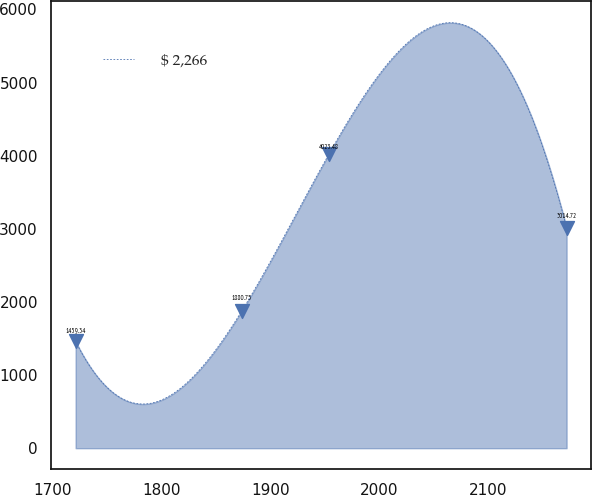Convert chart to OTSL. <chart><loc_0><loc_0><loc_500><loc_500><line_chart><ecel><fcel>$ 2,266<nl><fcel>1720.82<fcel>1459.34<nl><fcel>1873.73<fcel>1880.75<nl><fcel>1953.71<fcel>4023.48<nl><fcel>2172.24<fcel>3014.72<nl></chart> 